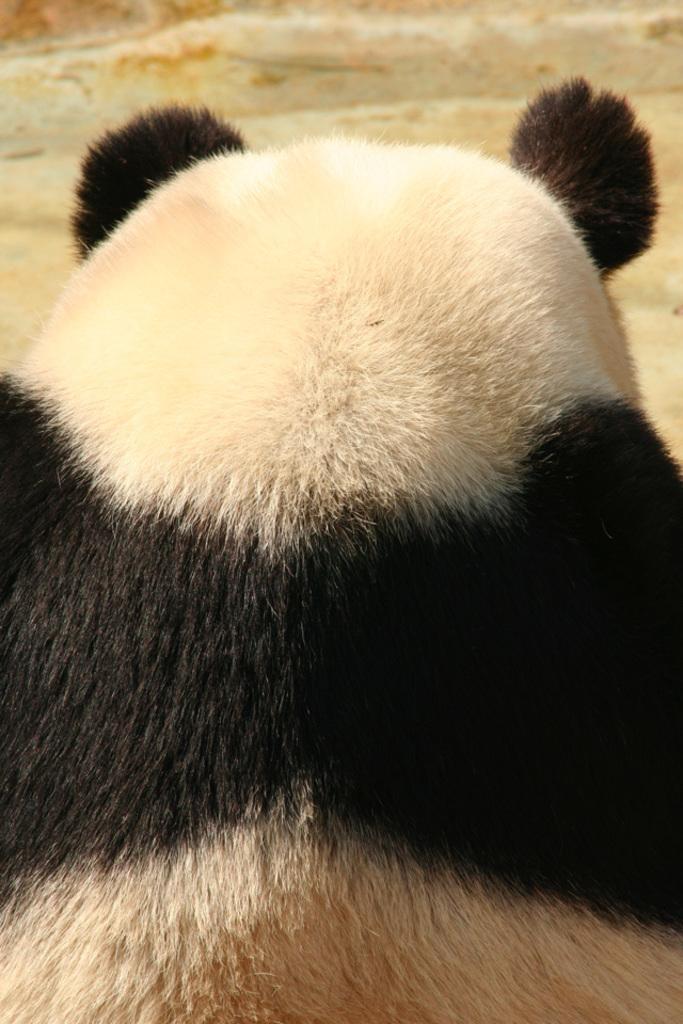Can you describe this image briefly? In this picture I can observe panda in the middle of the picture. The background is blurred. 